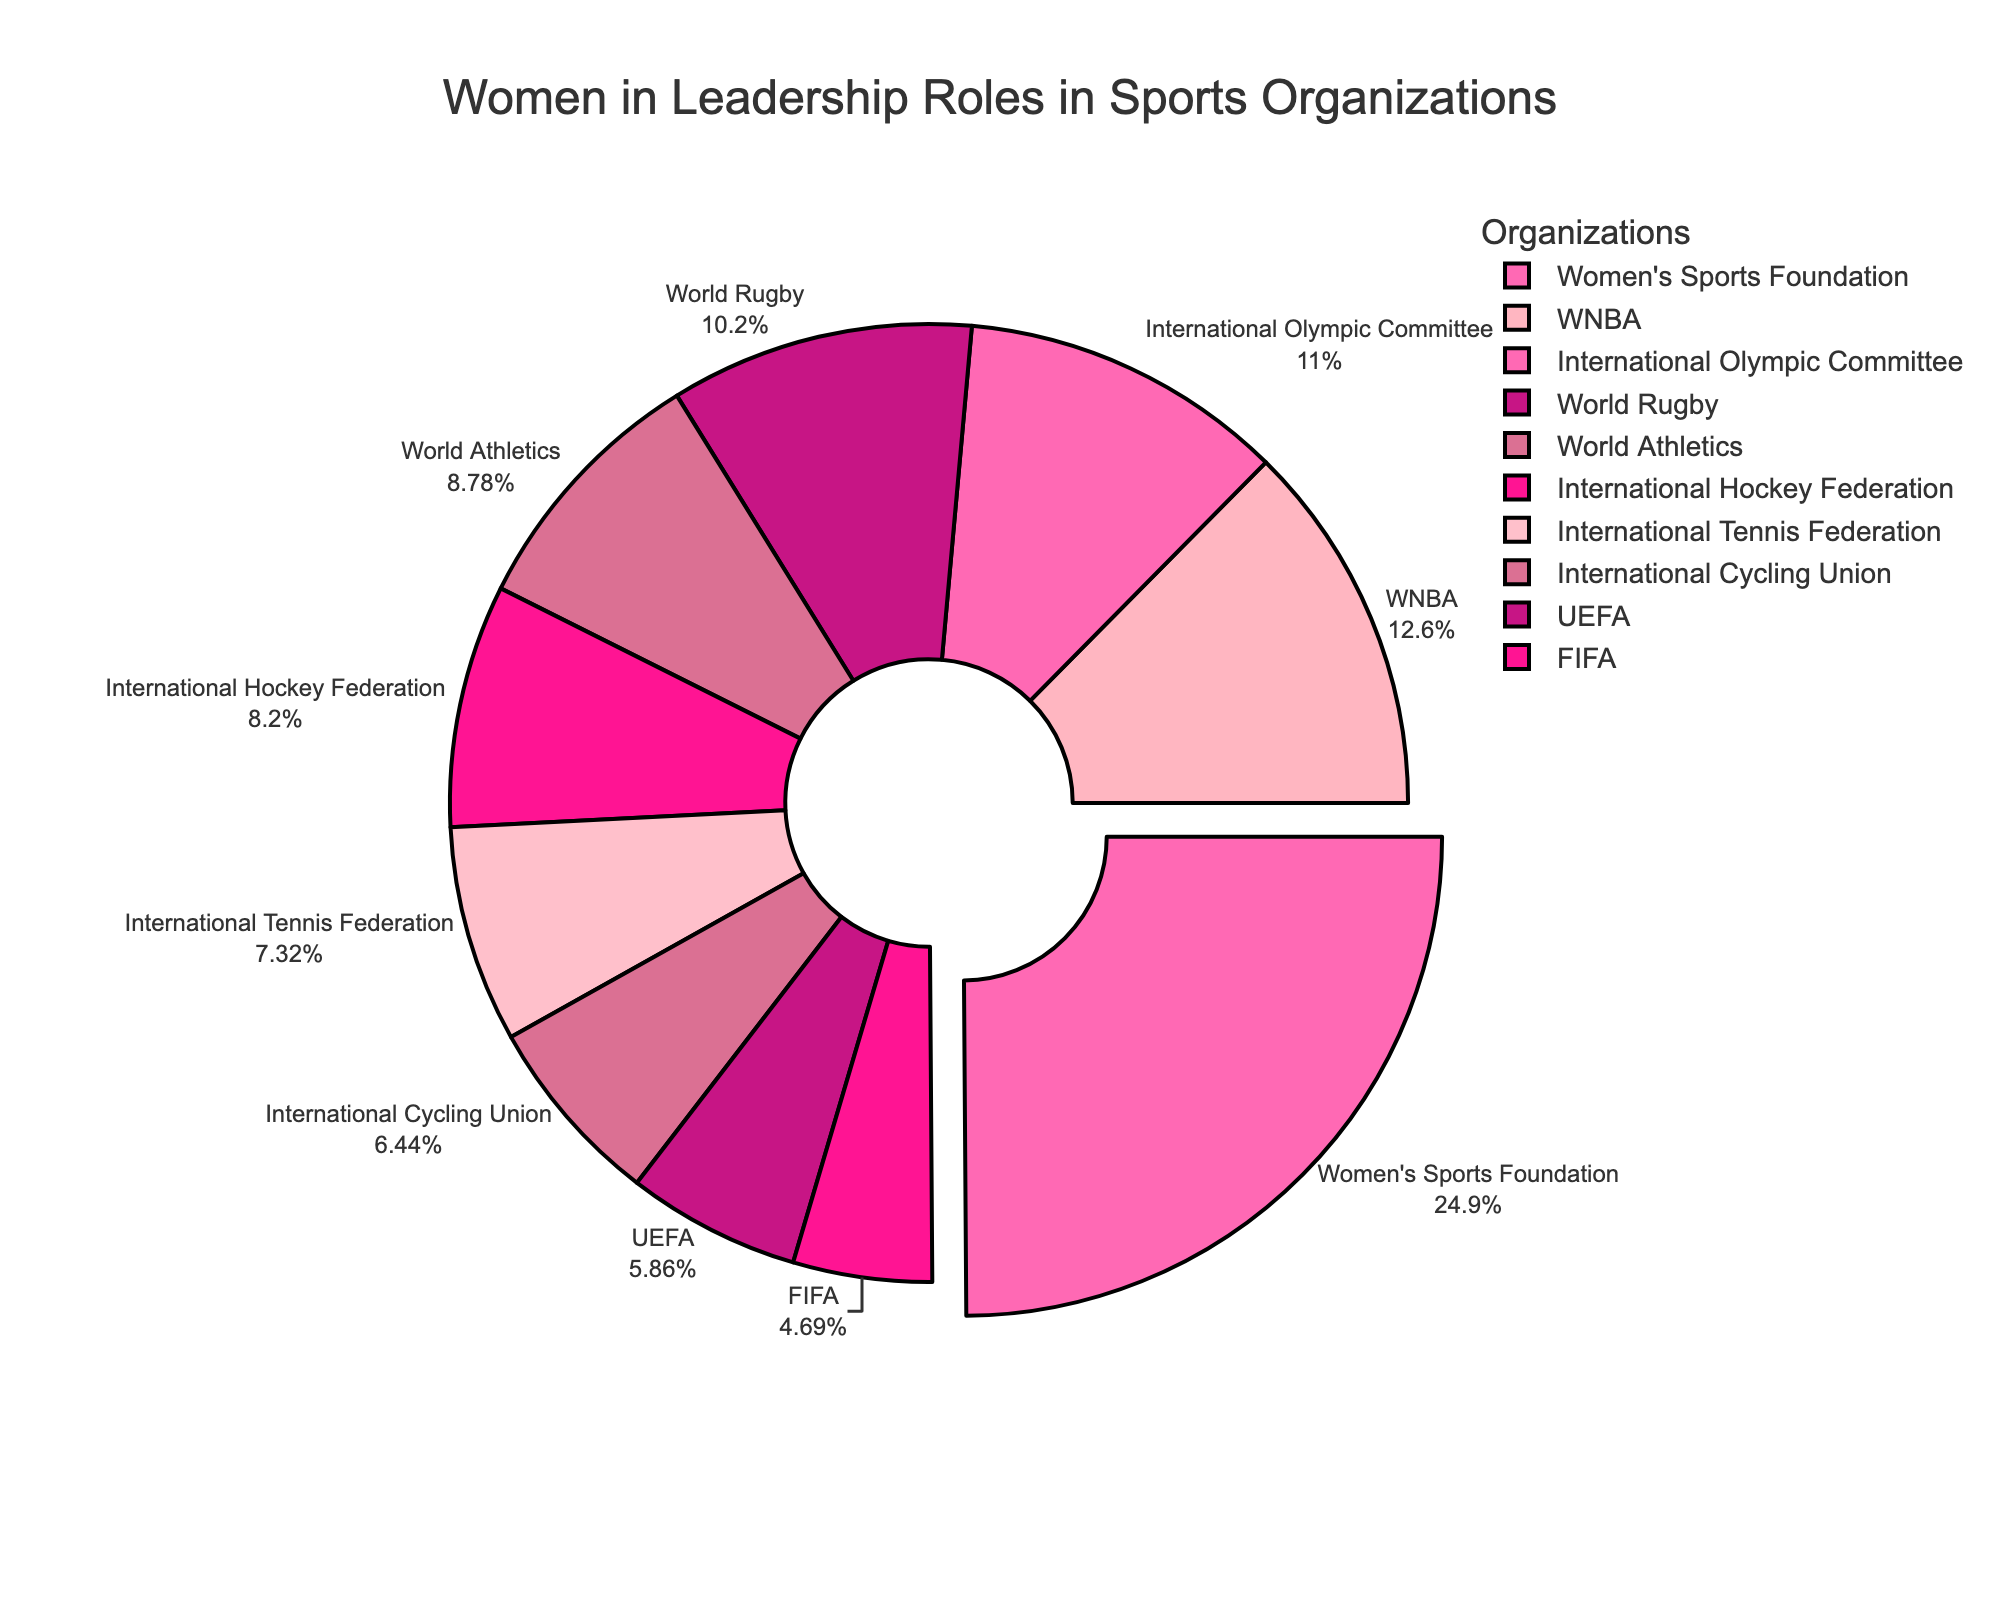What's the organization with the highest proportion of women in leadership roles? The figure shows a pie chart with different segments representing various organizations and their respective proportions of women in leadership roles. The segment with the highest proportion is the Women's Sports Foundation.
Answer: Women's Sports Foundation What organization has the lowest percentage of women in leadership roles? The segment with the smallest percentage value represents FIFA, which has the lowest proportion of women in leadership roles at 16%.
Answer: FIFA Compare the percentages of women in leadership roles between WNBA and International Olympic Committee. Which is higher? The WNBA's percentage is shown as 43%, while the International Olympic Committee's percentage is 37.5%. Therefore, WNBA has a higher percentage.
Answer: WNBA Calculate the difference in percentage points between World Rugby and the International Tennis Federation. The figure shows World Rugby with 35% and the International Tennis Federation with 25%. The difference is 35% - 25% = 10 percentage points.
Answer: 10 percentage points What is the combined percentage of women in leadership roles for all organizations shown? Sum the percentages given in the figure: 37.5 (IOC) + 16 (FIFA) + 20 (UEFA) + 30 (World Athletics) + 25 (ITF) + 43 (WNBA) + 85 (Women's Sports Foundation) + 28 (International Hockey Federation) + 35 (World Rugby) + 22 (International Cycling Union) = 341.5%.
Answer: 341.5% Which organizations have a higher percentage of women in leadership roles than the International Tennis Federation? The International Tennis Federation has 25%. Organizations with higher percentages are International Olympic Committee (37.5%), World Athletics (30%), WNBA (43%), Women's Sports Foundation (85%), World Rugby (35%).
Answer: International Olympic Committee, World Athletics, WNBA, Women's Sports Foundation, World Rugby Is the proportion of women in leadership roles in the International Volleyball Federation more than 30%? The International Volleyball Federation is not listed in the figure, so no data is available for this organization.
Answer: Not applicable Compare the percentage of women in leadership roles between International Cycling Union and International Hockey Federation and determine the larger value. The International Cycling Union has 22%, while the International Hockey Federation has 28%. Therefore, the International Hockey Federation has a larger value.
Answer: International Hockey Federation 